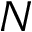Convert formula to latex. <formula><loc_0><loc_0><loc_500><loc_500>N</formula> 